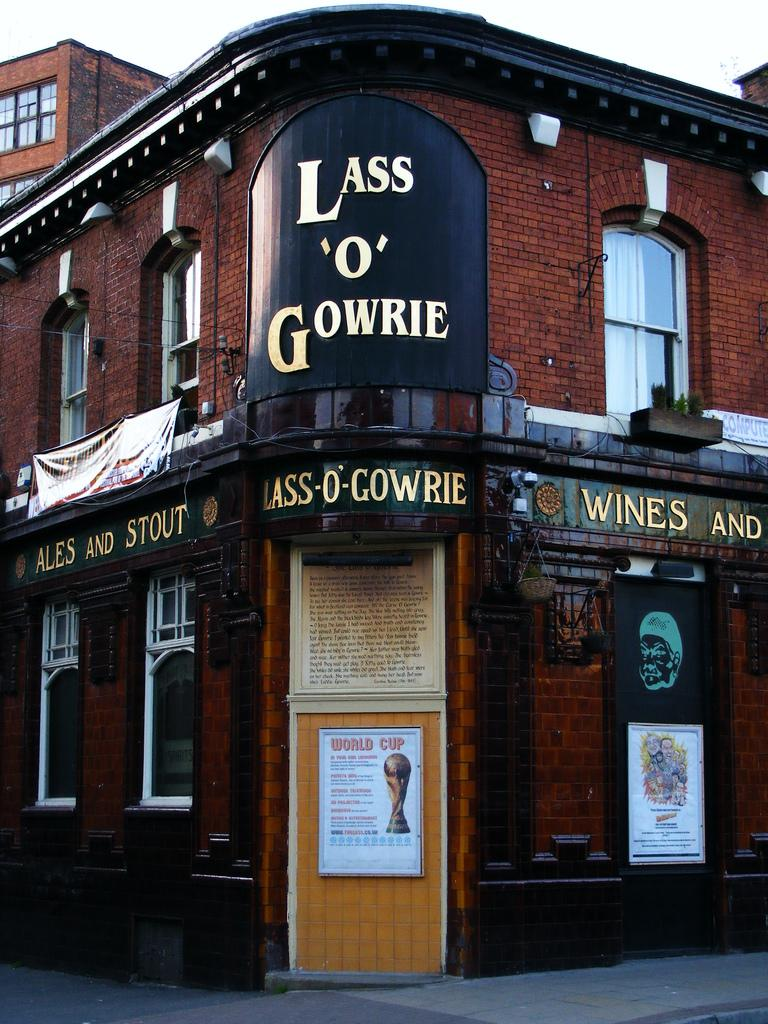What type of structure is present in the image? There is a building in the image. Where is the entrance to the building located? There is a door at the bottom of the image. What can be seen above the building in the image? The sky is visible at the top of the image. What type of sugar is used in the breakfast depicted in the image? There is no breakfast or sugar present in the image; it only features a building and a door. 